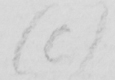What is written in this line of handwriting? (C) 